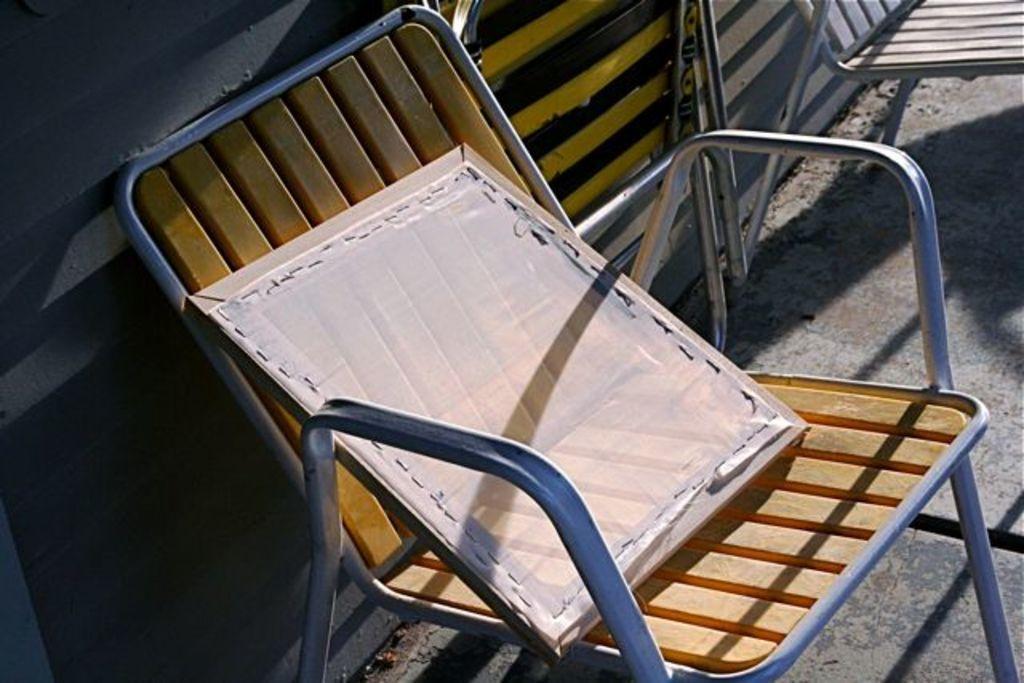Describe this image in one or two sentences. In this image, we can see a chair. Here there is an object is placed on it. At the bottom, we can see surface. Background there is a wall. Top of the image, we can see two chairs on the surface. 